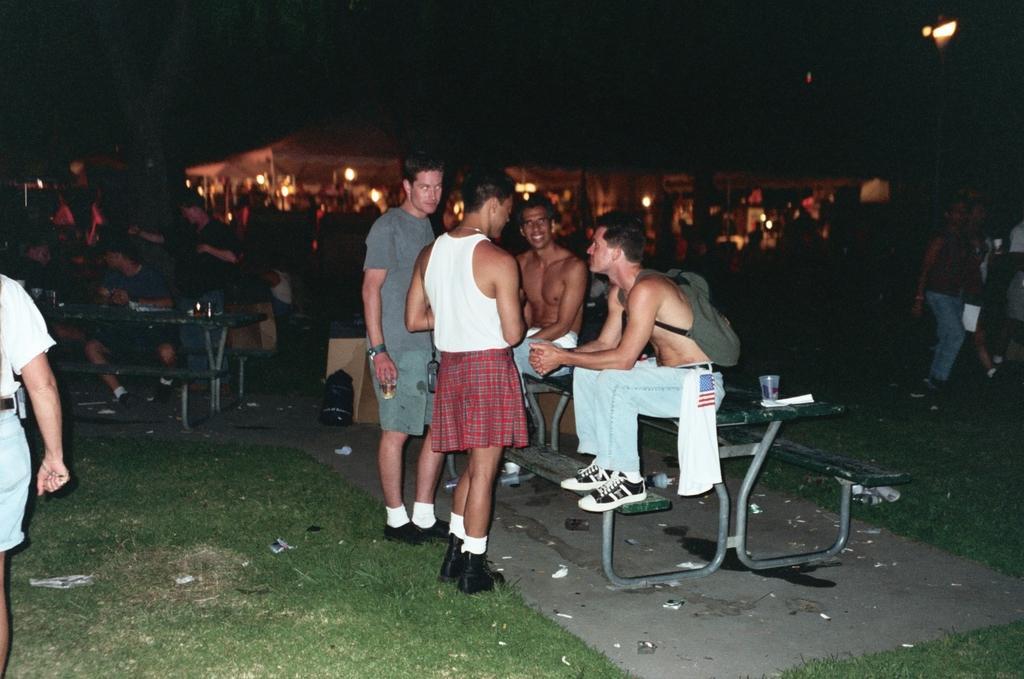In one or two sentences, can you explain what this image depicts? As we can see in the image there are group of people, tables, glass, lights, grass and in the background there are buildings. The image is little dark. 